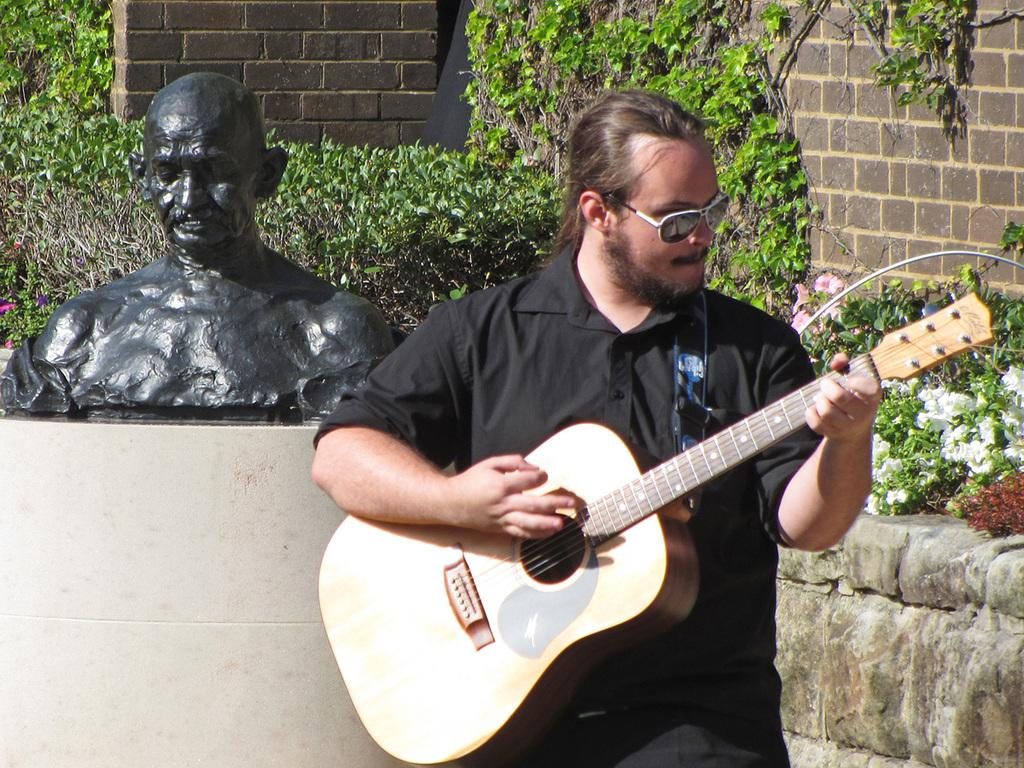What is the man in the image doing? The man is playing a guitar in the image. What is the man wearing on his face? The man is wearing goggles in the image. What type of artwork is the image? The image is a sculpture. What can be seen in the background of the image? There is a wall and plants in the background of the image. What type of business is being conducted in the image? There is no indication of a business or any commercial activity in the image, as it features a man playing a guitar in a sculpture. Can you tell me what the argument is about in the image? There is no argument or any conflict depicted in the image; it shows a man playing a guitar in a sculpture. 